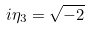<formula> <loc_0><loc_0><loc_500><loc_500>i \eta _ { 3 } = \sqrt { - 2 }</formula> 